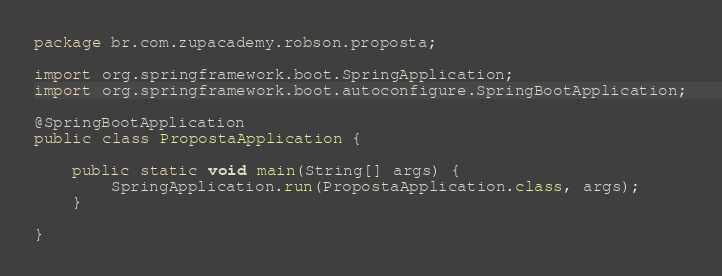<code> <loc_0><loc_0><loc_500><loc_500><_Java_>package br.com.zupacademy.robson.proposta;

import org.springframework.boot.SpringApplication;
import org.springframework.boot.autoconfigure.SpringBootApplication;

@SpringBootApplication
public class PropostaApplication {

	public static void main(String[] args) {
		SpringApplication.run(PropostaApplication.class, args);
	}

}
</code> 